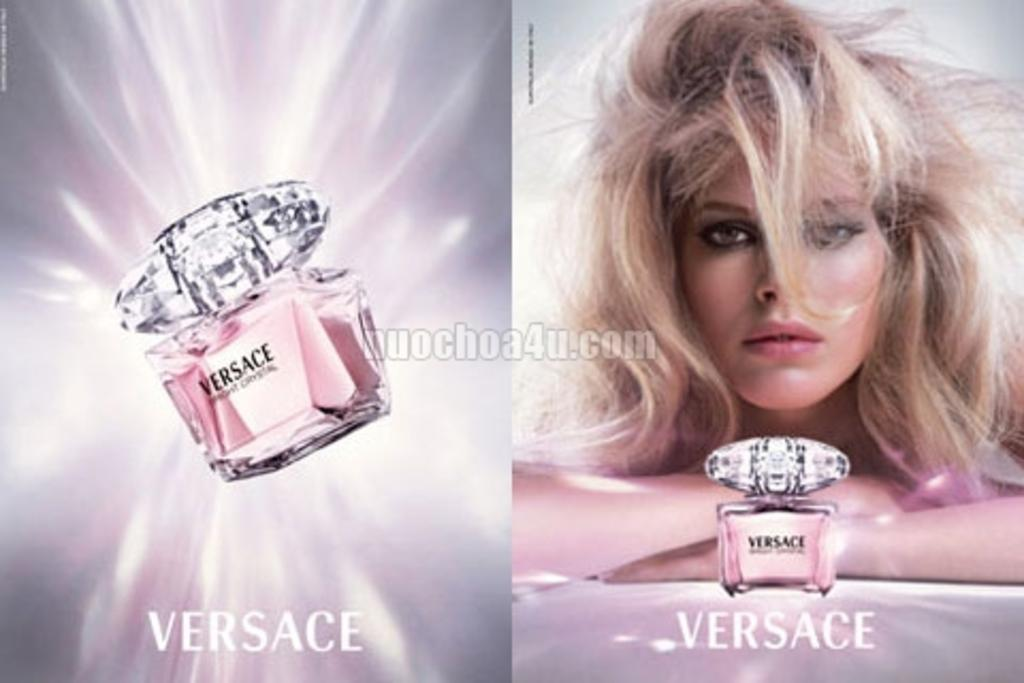<image>
Provide a brief description of the given image. An ad for Versace perfume has the image of a woman on one side. 